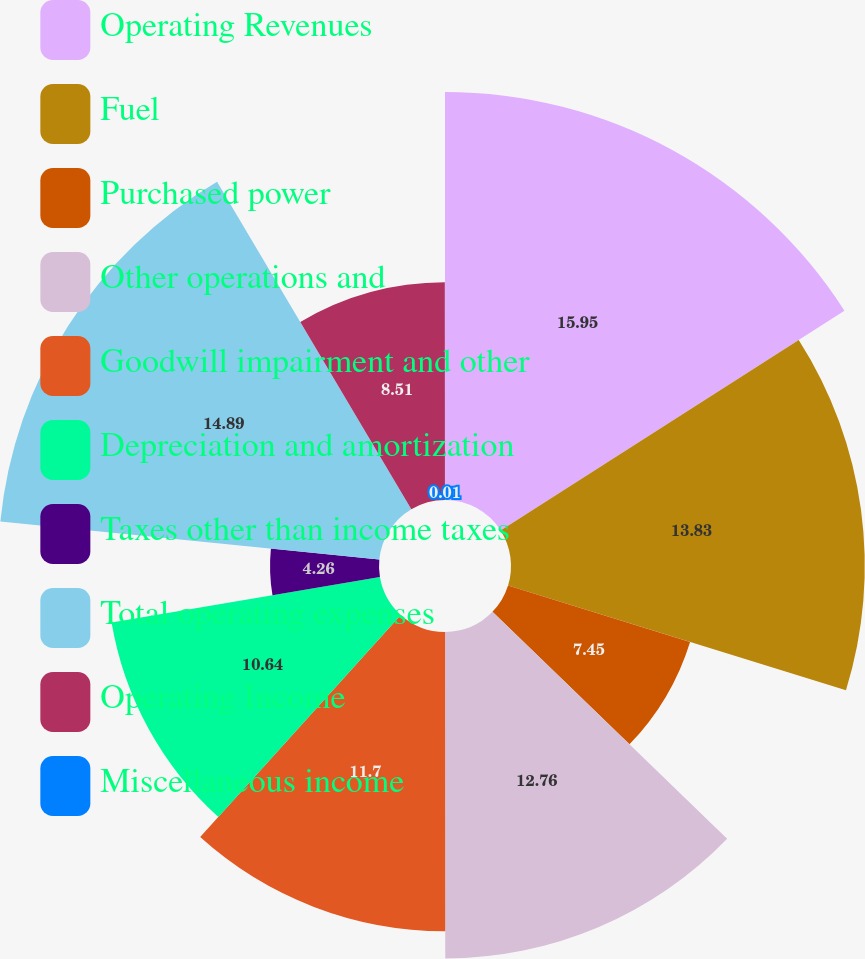<chart> <loc_0><loc_0><loc_500><loc_500><pie_chart><fcel>Operating Revenues<fcel>Fuel<fcel>Purchased power<fcel>Other operations and<fcel>Goodwill impairment and other<fcel>Depreciation and amortization<fcel>Taxes other than income taxes<fcel>Total operating expenses<fcel>Operating Income<fcel>Miscellaneous income<nl><fcel>15.95%<fcel>13.83%<fcel>7.45%<fcel>12.76%<fcel>11.7%<fcel>10.64%<fcel>4.26%<fcel>14.89%<fcel>8.51%<fcel>0.01%<nl></chart> 